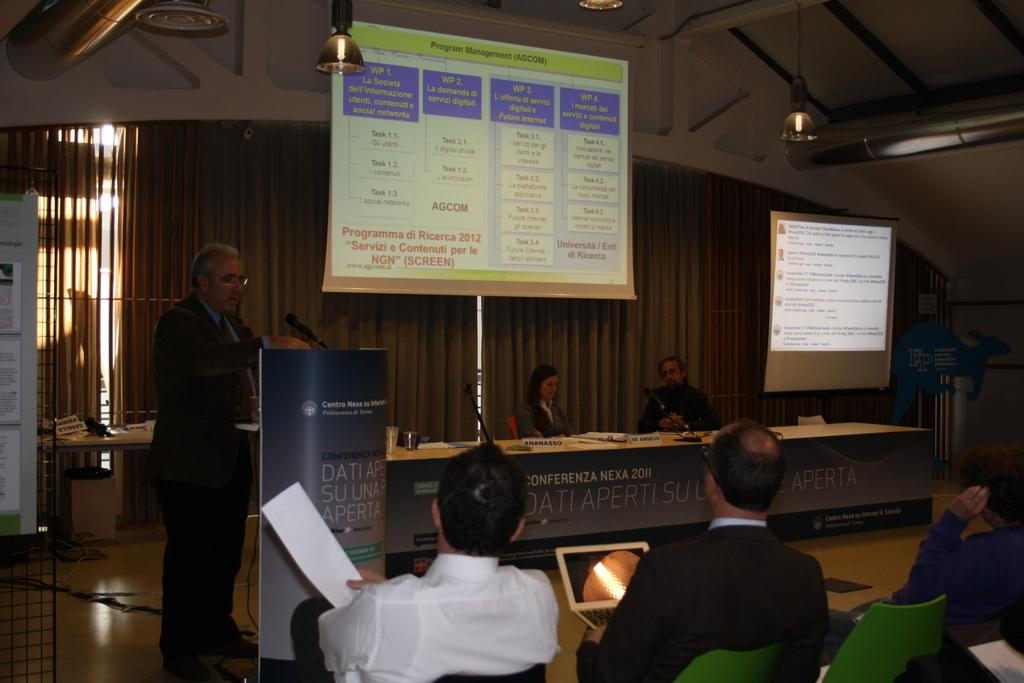What are the people in the image doing? The people in the image are sitting on chairs. Is there anyone standing in the image? Yes, there is a person standing in the image. What can be seen on the screens in the image? The facts do not specify what is on the screens, so we cannot answer that question definitively. What type of light is visible in the image? There is light visible in the image, but the facts do not specify the source or type of light. What type of pie is being served to the people sitting on chairs in the image? There is no pie present in the image; the facts mention people sitting on chairs and screens, but not any food items. 